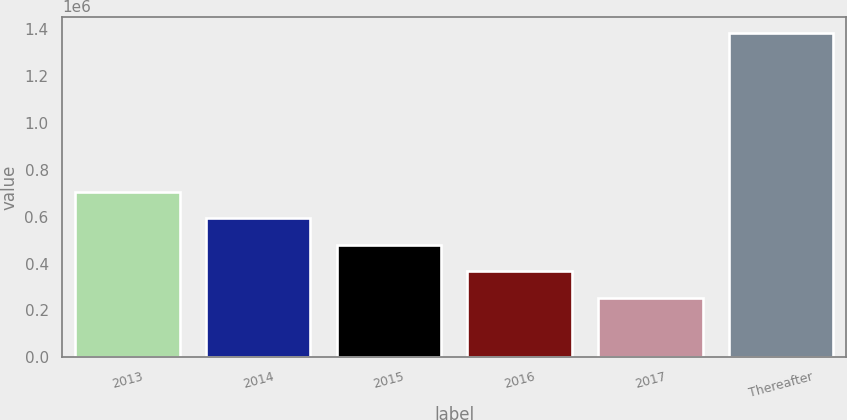Convert chart. <chart><loc_0><loc_0><loc_500><loc_500><bar_chart><fcel>2013<fcel>2014<fcel>2015<fcel>2016<fcel>2017<fcel>Thereafter<nl><fcel>706326<fcel>593348<fcel>480370<fcel>367391<fcel>254413<fcel>1.3842e+06<nl></chart> 